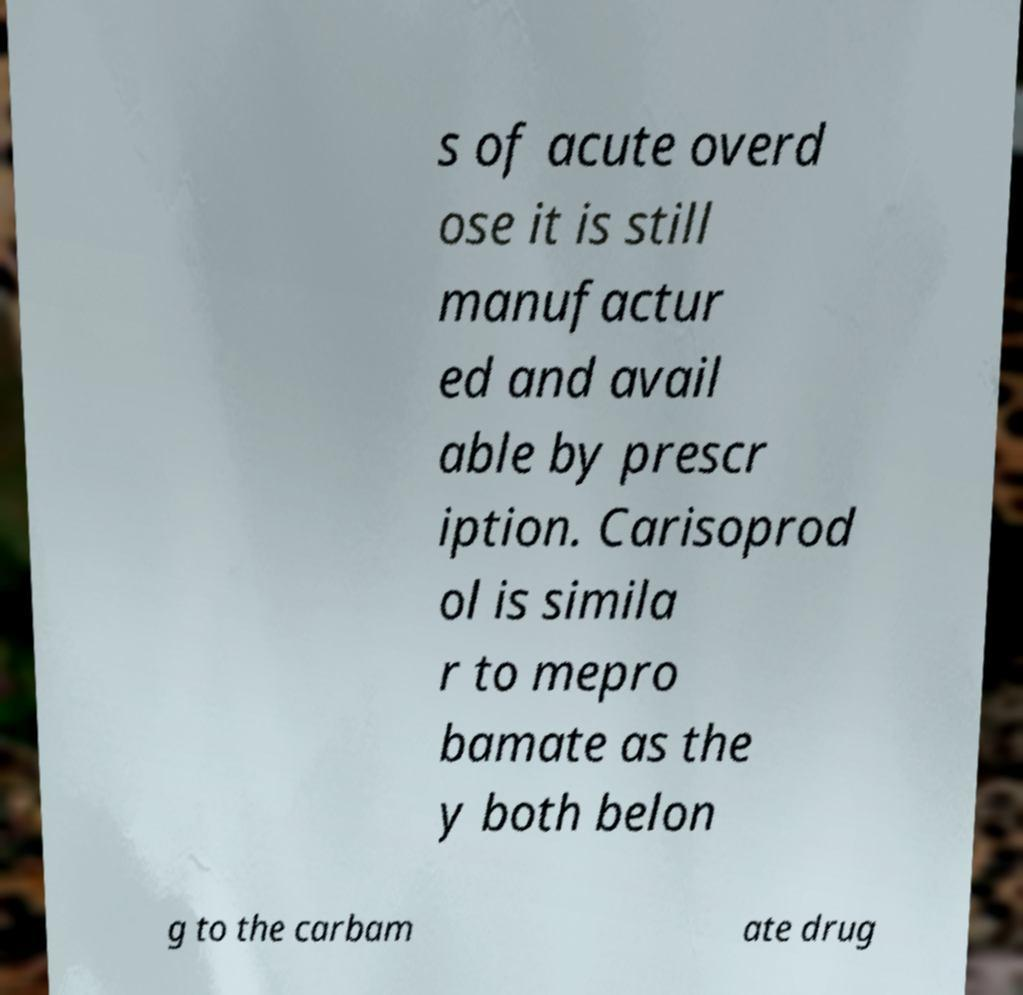Please read and relay the text visible in this image. What does it say? s of acute overd ose it is still manufactur ed and avail able by prescr iption. Carisoprod ol is simila r to mepro bamate as the y both belon g to the carbam ate drug 